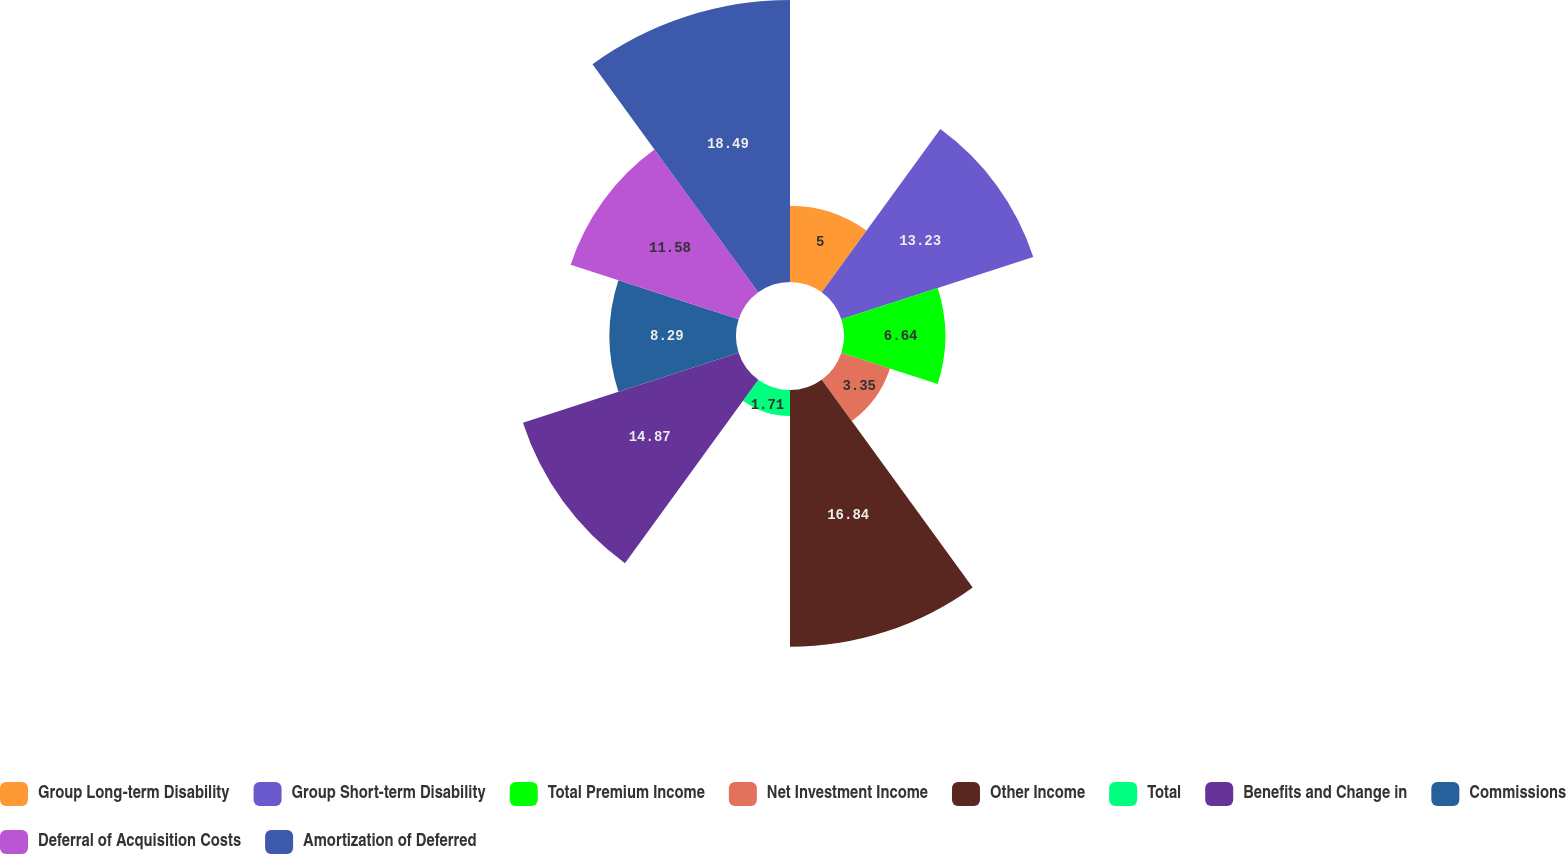Convert chart to OTSL. <chart><loc_0><loc_0><loc_500><loc_500><pie_chart><fcel>Group Long-term Disability<fcel>Group Short-term Disability<fcel>Total Premium Income<fcel>Net Investment Income<fcel>Other Income<fcel>Total<fcel>Benefits and Change in<fcel>Commissions<fcel>Deferral of Acquisition Costs<fcel>Amortization of Deferred<nl><fcel>5.0%<fcel>13.23%<fcel>6.64%<fcel>3.35%<fcel>16.84%<fcel>1.71%<fcel>14.87%<fcel>8.29%<fcel>11.58%<fcel>18.49%<nl></chart> 